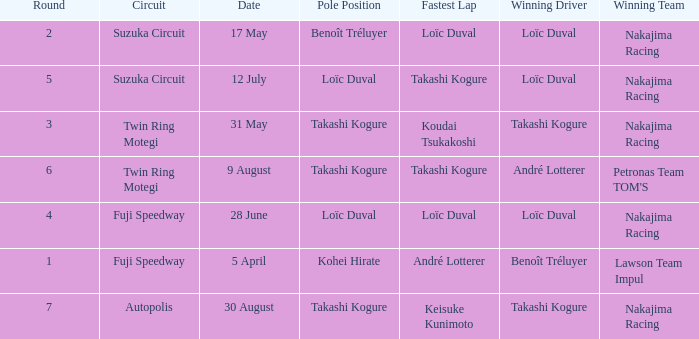What was the earlier round where Takashi Kogure got the fastest lap? 5.0. 